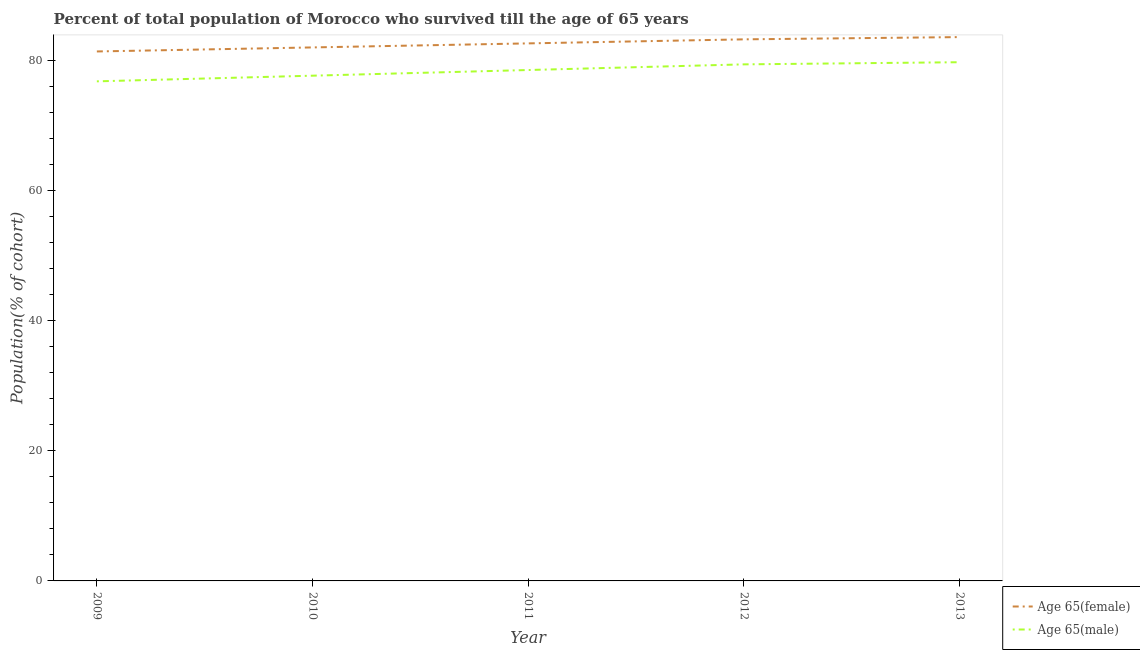Does the line corresponding to percentage of female population who survived till age of 65 intersect with the line corresponding to percentage of male population who survived till age of 65?
Offer a very short reply. No. What is the percentage of male population who survived till age of 65 in 2013?
Offer a very short reply. 79.7. Across all years, what is the maximum percentage of male population who survived till age of 65?
Offer a terse response. 79.7. Across all years, what is the minimum percentage of female population who survived till age of 65?
Keep it short and to the point. 81.35. In which year was the percentage of female population who survived till age of 65 maximum?
Your answer should be compact. 2013. What is the total percentage of male population who survived till age of 65 in the graph?
Your answer should be compact. 391.96. What is the difference between the percentage of male population who survived till age of 65 in 2012 and that in 2013?
Provide a short and direct response. -0.33. What is the difference between the percentage of female population who survived till age of 65 in 2010 and the percentage of male population who survived till age of 65 in 2009?
Provide a short and direct response. 5.21. What is the average percentage of female population who survived till age of 65 per year?
Give a very brief answer. 82.54. In the year 2012, what is the difference between the percentage of female population who survived till age of 65 and percentage of male population who survived till age of 65?
Offer a terse response. 3.84. What is the ratio of the percentage of male population who survived till age of 65 in 2010 to that in 2011?
Your answer should be very brief. 0.99. Is the percentage of female population who survived till age of 65 in 2011 less than that in 2013?
Your response must be concise. Yes. Is the difference between the percentage of male population who survived till age of 65 in 2011 and 2012 greater than the difference between the percentage of female population who survived till age of 65 in 2011 and 2012?
Your answer should be compact. No. What is the difference between the highest and the second highest percentage of female population who survived till age of 65?
Offer a terse response. 0.35. What is the difference between the highest and the lowest percentage of male population who survived till age of 65?
Offer a very short reply. 2.94. Is the sum of the percentage of male population who survived till age of 65 in 2010 and 2012 greater than the maximum percentage of female population who survived till age of 65 across all years?
Provide a succinct answer. Yes. Is the percentage of male population who survived till age of 65 strictly less than the percentage of female population who survived till age of 65 over the years?
Your answer should be very brief. Yes. How many lines are there?
Give a very brief answer. 2. Where does the legend appear in the graph?
Ensure brevity in your answer.  Bottom right. What is the title of the graph?
Your answer should be very brief. Percent of total population of Morocco who survived till the age of 65 years. Does "Forest land" appear as one of the legend labels in the graph?
Provide a succinct answer. No. What is the label or title of the Y-axis?
Ensure brevity in your answer.  Population(% of cohort). What is the Population(% of cohort) in Age 65(female) in 2009?
Your answer should be compact. 81.35. What is the Population(% of cohort) of Age 65(male) in 2009?
Your answer should be very brief. 76.76. What is the Population(% of cohort) of Age 65(female) in 2010?
Ensure brevity in your answer.  81.97. What is the Population(% of cohort) of Age 65(male) in 2010?
Keep it short and to the point. 77.63. What is the Population(% of cohort) in Age 65(female) in 2011?
Keep it short and to the point. 82.59. What is the Population(% of cohort) of Age 65(male) in 2011?
Provide a succinct answer. 78.5. What is the Population(% of cohort) of Age 65(female) in 2012?
Make the answer very short. 83.21. What is the Population(% of cohort) in Age 65(male) in 2012?
Ensure brevity in your answer.  79.37. What is the Population(% of cohort) in Age 65(female) in 2013?
Provide a short and direct response. 83.56. What is the Population(% of cohort) in Age 65(male) in 2013?
Provide a short and direct response. 79.7. Across all years, what is the maximum Population(% of cohort) in Age 65(female)?
Your answer should be compact. 83.56. Across all years, what is the maximum Population(% of cohort) in Age 65(male)?
Provide a succinct answer. 79.7. Across all years, what is the minimum Population(% of cohort) of Age 65(female)?
Make the answer very short. 81.35. Across all years, what is the minimum Population(% of cohort) in Age 65(male)?
Give a very brief answer. 76.76. What is the total Population(% of cohort) of Age 65(female) in the graph?
Ensure brevity in your answer.  412.69. What is the total Population(% of cohort) in Age 65(male) in the graph?
Provide a short and direct response. 391.96. What is the difference between the Population(% of cohort) of Age 65(female) in 2009 and that in 2010?
Provide a succinct answer. -0.62. What is the difference between the Population(% of cohort) of Age 65(male) in 2009 and that in 2010?
Offer a terse response. -0.87. What is the difference between the Population(% of cohort) in Age 65(female) in 2009 and that in 2011?
Your answer should be very brief. -1.24. What is the difference between the Population(% of cohort) in Age 65(male) in 2009 and that in 2011?
Keep it short and to the point. -1.74. What is the difference between the Population(% of cohort) of Age 65(female) in 2009 and that in 2012?
Keep it short and to the point. -1.86. What is the difference between the Population(% of cohort) in Age 65(male) in 2009 and that in 2012?
Provide a succinct answer. -2.61. What is the difference between the Population(% of cohort) of Age 65(female) in 2009 and that in 2013?
Provide a succinct answer. -2.21. What is the difference between the Population(% of cohort) in Age 65(male) in 2009 and that in 2013?
Your answer should be compact. -2.94. What is the difference between the Population(% of cohort) in Age 65(female) in 2010 and that in 2011?
Your answer should be compact. -0.62. What is the difference between the Population(% of cohort) in Age 65(male) in 2010 and that in 2011?
Give a very brief answer. -0.87. What is the difference between the Population(% of cohort) of Age 65(female) in 2010 and that in 2012?
Your response must be concise. -1.24. What is the difference between the Population(% of cohort) of Age 65(male) in 2010 and that in 2012?
Your answer should be compact. -1.74. What is the difference between the Population(% of cohort) in Age 65(female) in 2010 and that in 2013?
Keep it short and to the point. -1.59. What is the difference between the Population(% of cohort) of Age 65(male) in 2010 and that in 2013?
Your response must be concise. -2.07. What is the difference between the Population(% of cohort) in Age 65(female) in 2011 and that in 2012?
Your answer should be very brief. -0.62. What is the difference between the Population(% of cohort) of Age 65(male) in 2011 and that in 2012?
Your response must be concise. -0.87. What is the difference between the Population(% of cohort) of Age 65(female) in 2011 and that in 2013?
Keep it short and to the point. -0.97. What is the difference between the Population(% of cohort) in Age 65(male) in 2011 and that in 2013?
Make the answer very short. -1.2. What is the difference between the Population(% of cohort) in Age 65(female) in 2012 and that in 2013?
Offer a very short reply. -0.35. What is the difference between the Population(% of cohort) of Age 65(male) in 2012 and that in 2013?
Offer a terse response. -0.33. What is the difference between the Population(% of cohort) in Age 65(female) in 2009 and the Population(% of cohort) in Age 65(male) in 2010?
Make the answer very short. 3.72. What is the difference between the Population(% of cohort) of Age 65(female) in 2009 and the Population(% of cohort) of Age 65(male) in 2011?
Offer a terse response. 2.85. What is the difference between the Population(% of cohort) of Age 65(female) in 2009 and the Population(% of cohort) of Age 65(male) in 2012?
Your answer should be very brief. 1.98. What is the difference between the Population(% of cohort) of Age 65(female) in 2009 and the Population(% of cohort) of Age 65(male) in 2013?
Ensure brevity in your answer.  1.65. What is the difference between the Population(% of cohort) of Age 65(female) in 2010 and the Population(% of cohort) of Age 65(male) in 2011?
Ensure brevity in your answer.  3.47. What is the difference between the Population(% of cohort) in Age 65(female) in 2010 and the Population(% of cohort) in Age 65(male) in 2012?
Your answer should be compact. 2.6. What is the difference between the Population(% of cohort) in Age 65(female) in 2010 and the Population(% of cohort) in Age 65(male) in 2013?
Your answer should be compact. 2.27. What is the difference between the Population(% of cohort) of Age 65(female) in 2011 and the Population(% of cohort) of Age 65(male) in 2012?
Your response must be concise. 3.22. What is the difference between the Population(% of cohort) of Age 65(female) in 2011 and the Population(% of cohort) of Age 65(male) in 2013?
Ensure brevity in your answer.  2.89. What is the difference between the Population(% of cohort) of Age 65(female) in 2012 and the Population(% of cohort) of Age 65(male) in 2013?
Give a very brief answer. 3.51. What is the average Population(% of cohort) in Age 65(female) per year?
Give a very brief answer. 82.54. What is the average Population(% of cohort) of Age 65(male) per year?
Your response must be concise. 78.39. In the year 2009, what is the difference between the Population(% of cohort) in Age 65(female) and Population(% of cohort) in Age 65(male)?
Keep it short and to the point. 4.59. In the year 2010, what is the difference between the Population(% of cohort) of Age 65(female) and Population(% of cohort) of Age 65(male)?
Provide a succinct answer. 4.34. In the year 2011, what is the difference between the Population(% of cohort) in Age 65(female) and Population(% of cohort) in Age 65(male)?
Keep it short and to the point. 4.09. In the year 2012, what is the difference between the Population(% of cohort) in Age 65(female) and Population(% of cohort) in Age 65(male)?
Offer a terse response. 3.84. In the year 2013, what is the difference between the Population(% of cohort) in Age 65(female) and Population(% of cohort) in Age 65(male)?
Your response must be concise. 3.86. What is the ratio of the Population(% of cohort) in Age 65(female) in 2009 to that in 2011?
Keep it short and to the point. 0.98. What is the ratio of the Population(% of cohort) of Age 65(male) in 2009 to that in 2011?
Give a very brief answer. 0.98. What is the ratio of the Population(% of cohort) in Age 65(female) in 2009 to that in 2012?
Offer a terse response. 0.98. What is the ratio of the Population(% of cohort) in Age 65(male) in 2009 to that in 2012?
Offer a terse response. 0.97. What is the ratio of the Population(% of cohort) in Age 65(female) in 2009 to that in 2013?
Your answer should be compact. 0.97. What is the ratio of the Population(% of cohort) in Age 65(male) in 2009 to that in 2013?
Keep it short and to the point. 0.96. What is the ratio of the Population(% of cohort) in Age 65(female) in 2010 to that in 2011?
Give a very brief answer. 0.99. What is the ratio of the Population(% of cohort) of Age 65(male) in 2010 to that in 2011?
Your answer should be compact. 0.99. What is the ratio of the Population(% of cohort) in Age 65(female) in 2010 to that in 2012?
Your answer should be compact. 0.99. What is the ratio of the Population(% of cohort) of Age 65(male) in 2010 to that in 2012?
Offer a very short reply. 0.98. What is the ratio of the Population(% of cohort) in Age 65(female) in 2010 to that in 2013?
Provide a short and direct response. 0.98. What is the ratio of the Population(% of cohort) in Age 65(female) in 2011 to that in 2012?
Provide a short and direct response. 0.99. What is the ratio of the Population(% of cohort) of Age 65(female) in 2011 to that in 2013?
Your answer should be compact. 0.99. What is the ratio of the Population(% of cohort) in Age 65(male) in 2011 to that in 2013?
Your response must be concise. 0.98. What is the ratio of the Population(% of cohort) in Age 65(male) in 2012 to that in 2013?
Provide a succinct answer. 1. What is the difference between the highest and the second highest Population(% of cohort) in Age 65(female)?
Ensure brevity in your answer.  0.35. What is the difference between the highest and the second highest Population(% of cohort) of Age 65(male)?
Keep it short and to the point. 0.33. What is the difference between the highest and the lowest Population(% of cohort) in Age 65(female)?
Your answer should be very brief. 2.21. What is the difference between the highest and the lowest Population(% of cohort) in Age 65(male)?
Offer a very short reply. 2.94. 